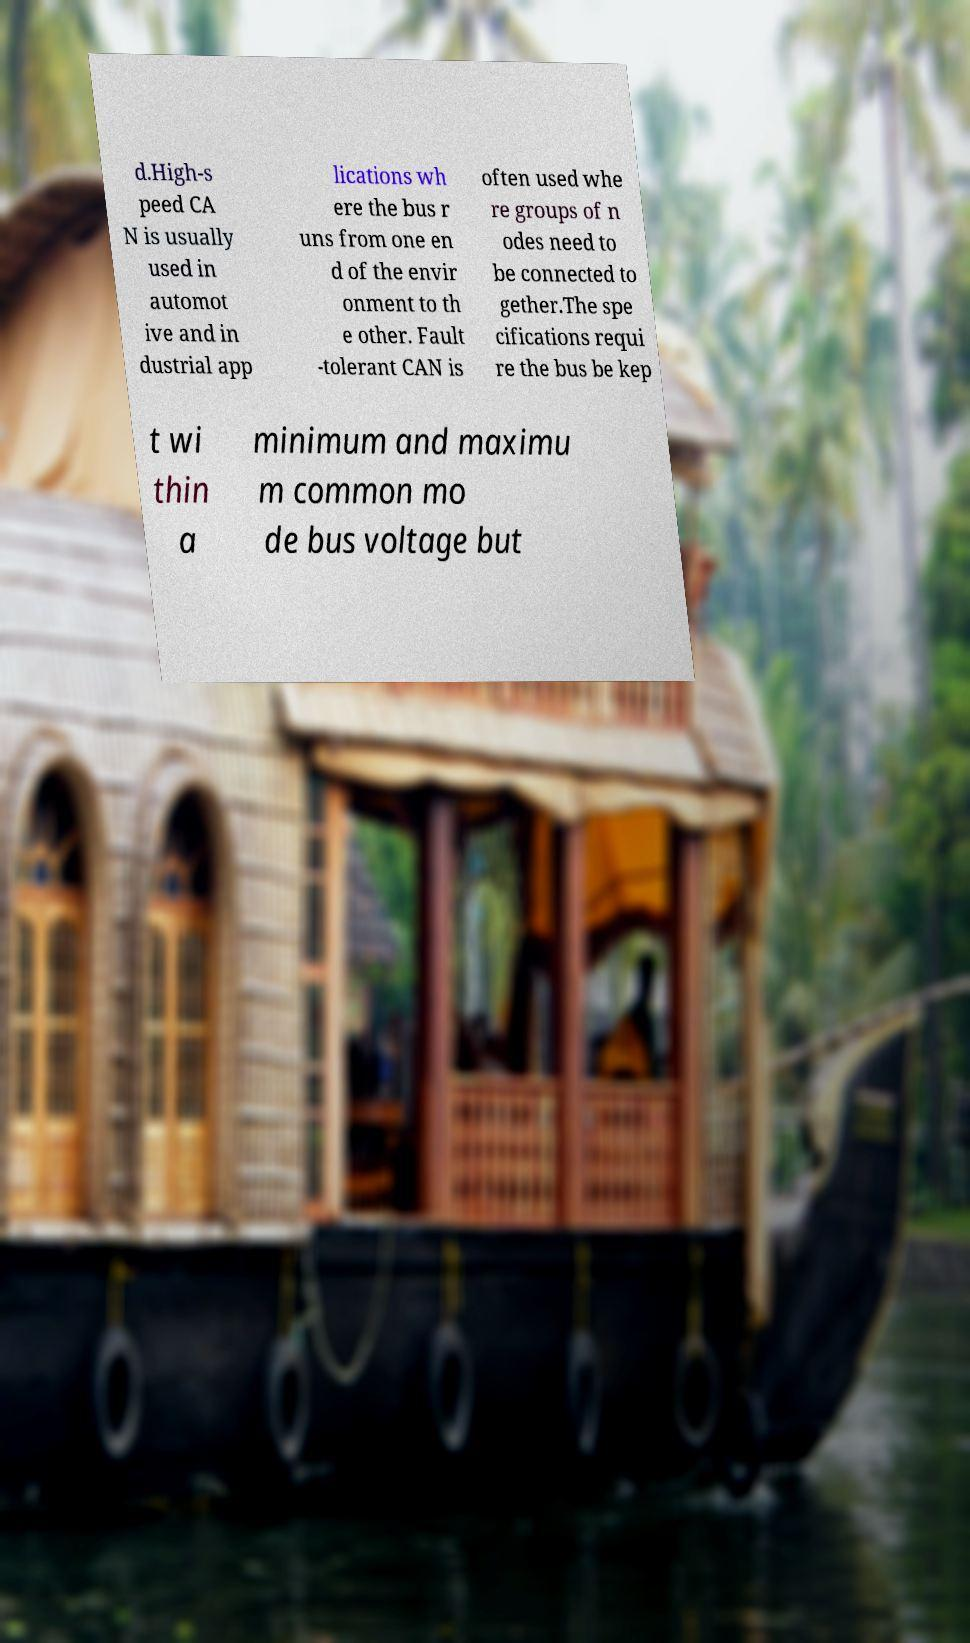For documentation purposes, I need the text within this image transcribed. Could you provide that? d.High-s peed CA N is usually used in automot ive and in dustrial app lications wh ere the bus r uns from one en d of the envir onment to th e other. Fault -tolerant CAN is often used whe re groups of n odes need to be connected to gether.The spe cifications requi re the bus be kep t wi thin a minimum and maximu m common mo de bus voltage but 